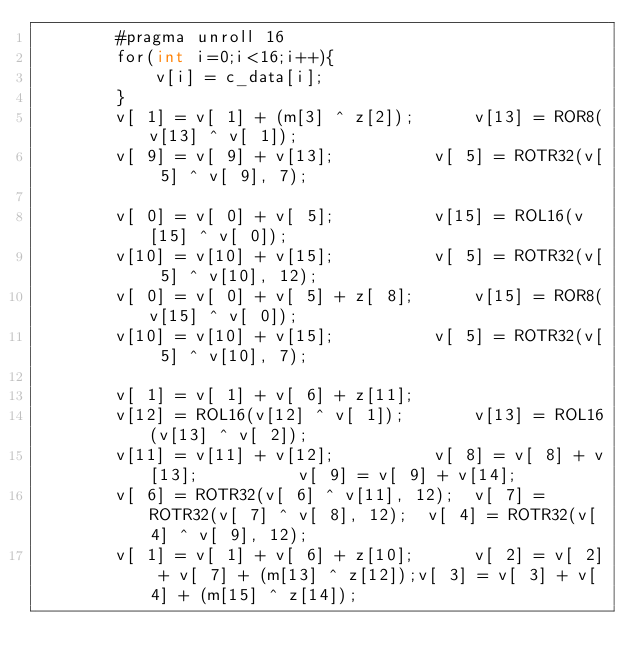Convert code to text. <code><loc_0><loc_0><loc_500><loc_500><_Cuda_>		#pragma unroll 16
		for(int i=0;i<16;i++){
			v[i] = c_data[i];
		}
		v[ 1] = v[ 1] + (m[3] ^ z[2]);		v[13] = ROR8(v[13] ^ v[ 1]);
		v[ 9] = v[ 9] + v[13];			v[ 5] = ROTR32(v[ 5] ^ v[ 9], 7);
		
		v[ 0] = v[ 0] + v[ 5];			v[15] = ROL16(v[15] ^ v[ 0]);
		v[10] = v[10] + v[15];			v[ 5] = ROTR32(v[ 5] ^ v[10], 12);
		v[ 0] = v[ 0] + v[ 5] + z[ 8];		v[15] = ROR8(v[15] ^ v[ 0]);
		v[10] = v[10] + v[15];			v[ 5] = ROTR32(v[ 5] ^ v[10], 7);

		v[ 1] = v[ 1] + v[ 6] + z[11];
		v[12] = ROL16(v[12] ^ v[ 1]);		v[13] = ROL16(v[13] ^ v[ 2]);
		v[11] = v[11] + v[12];			v[ 8] = v[ 8] + v[13];			v[ 9] = v[ 9] + v[14];
		v[ 6] = ROTR32(v[ 6] ^ v[11], 12);	v[ 7] = ROTR32(v[ 7] ^ v[ 8], 12);	v[ 4] = ROTR32(v[ 4] ^ v[ 9], 12);
		v[ 1] = v[ 1] + v[ 6] + z[10];		v[ 2] = v[ 2] + v[ 7] + (m[13] ^ z[12]);v[ 3] = v[ 3] + v[ 4] + (m[15] ^ z[14]);</code> 